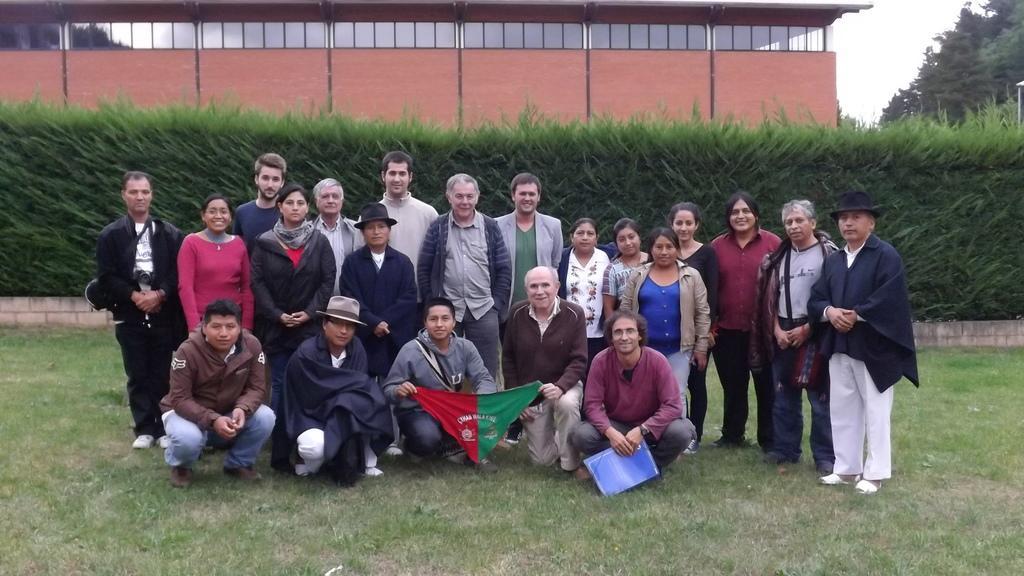Please provide a concise description of this image. In this picture there are group of people in the center of the image on the grassland and there is greenery and a building in the background area of the image. 